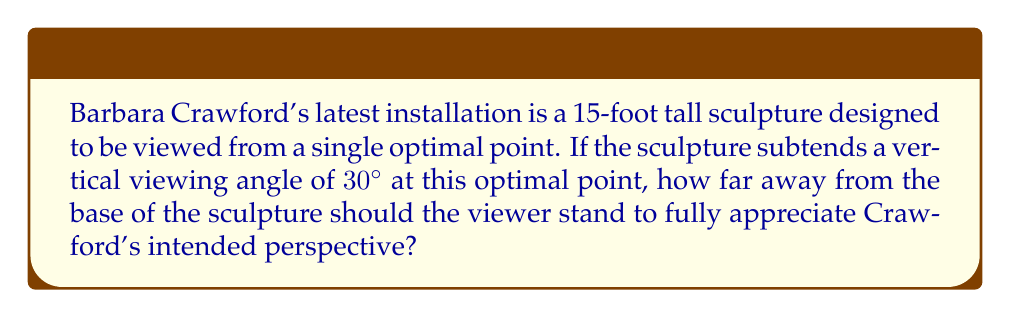Help me with this question. Let's approach this step-by-step using perspective geometry:

1) We can model this situation as a right triangle, where:
   - The height of the sculpture is the opposite side
   - The viewing distance is the adjacent side
   - The viewing angle is the angle between these two sides

2) We know:
   - The height of the sculpture, $h = 15$ feet
   - The viewing angle, $\theta = 30°$

3) We need to find the viewing distance, let's call it $d$.

4) In a right triangle, the tangent of an angle is the ratio of the opposite side to the adjacent side:

   $$\tan \theta = \frac{\text{opposite}}{\text{adjacent}} = \frac{h}{d}$$

5) Substituting our known values:

   $$\tan 30° = \frac{15}{d}$$

6) We know that $\tan 30° = \frac{1}{\sqrt{3}}$, so:

   $$\frac{1}{\sqrt{3}} = \frac{15}{d}$$

7) Cross-multiplying:

   $$d = 15\sqrt{3}$$

8) Simplifying:

   $$d \approx 25.98 \text{ feet}$$

Therefore, the optimal viewing distance is approximately 26 feet from the base of the sculpture.

[asy]
import geometry;

size(200);

pair A = (0,0), B = (0,15), C = (26,0);
draw(A--B--C--A);

label("15 ft", (0,7.5), W);
label("26 ft", (13,-1), S);
label("30°", (2,0), NE);

draw(arc(A,2,0,30), Arrow);
[/asy]
Answer: $15\sqrt{3} \approx 26 \text{ feet}$ 